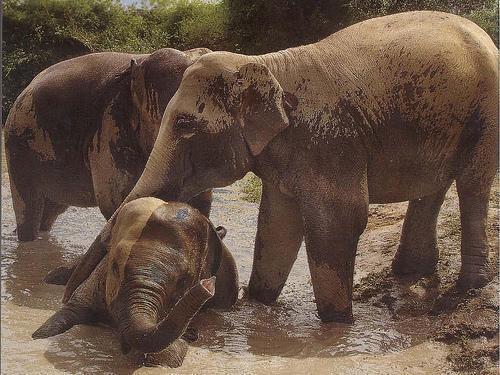How many elephants are there?
Give a very brief answer. 3. 